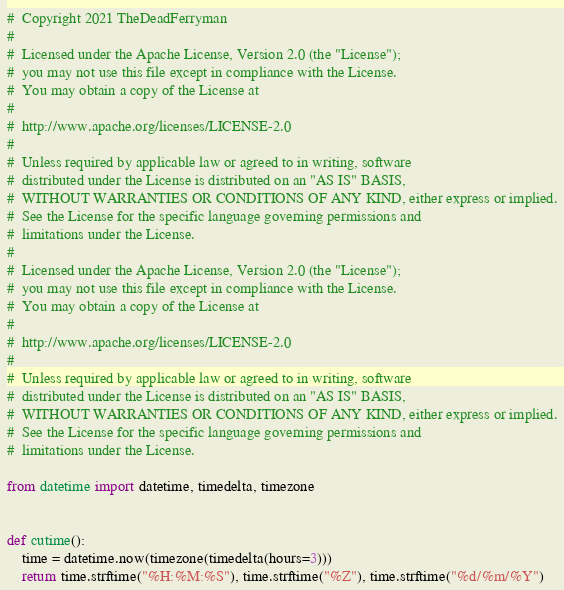<code> <loc_0><loc_0><loc_500><loc_500><_Python_>#  Copyright 2021 TheDeadFerryman
#
#  Licensed under the Apache License, Version 2.0 (the "License");
#  you may not use this file except in compliance with the License.
#  You may obtain a copy of the License at
#
#  http://www.apache.org/licenses/LICENSE-2.0
#
#  Unless required by applicable law or agreed to in writing, software
#  distributed under the License is distributed on an "AS IS" BASIS,
#  WITHOUT WARRANTIES OR CONDITIONS OF ANY KIND, either express or implied.
#  See the License for the specific language governing permissions and
#  limitations under the License.
#
#  Licensed under the Apache License, Version 2.0 (the "License");
#  you may not use this file except in compliance with the License.
#  You may obtain a copy of the License at
#
#  http://www.apache.org/licenses/LICENSE-2.0
#
#  Unless required by applicable law or agreed to in writing, software
#  distributed under the License is distributed on an "AS IS" BASIS,
#  WITHOUT WARRANTIES OR CONDITIONS OF ANY KIND, either express or implied.
#  See the License for the specific language governing permissions and
#  limitations under the License.

from datetime import datetime, timedelta, timezone


def cutime():
	time = datetime.now(timezone(timedelta(hours=3)))
	return time.strftime("%H:%M:%S"), time.strftime("%Z"), time.strftime("%d/%m/%Y")
</code> 